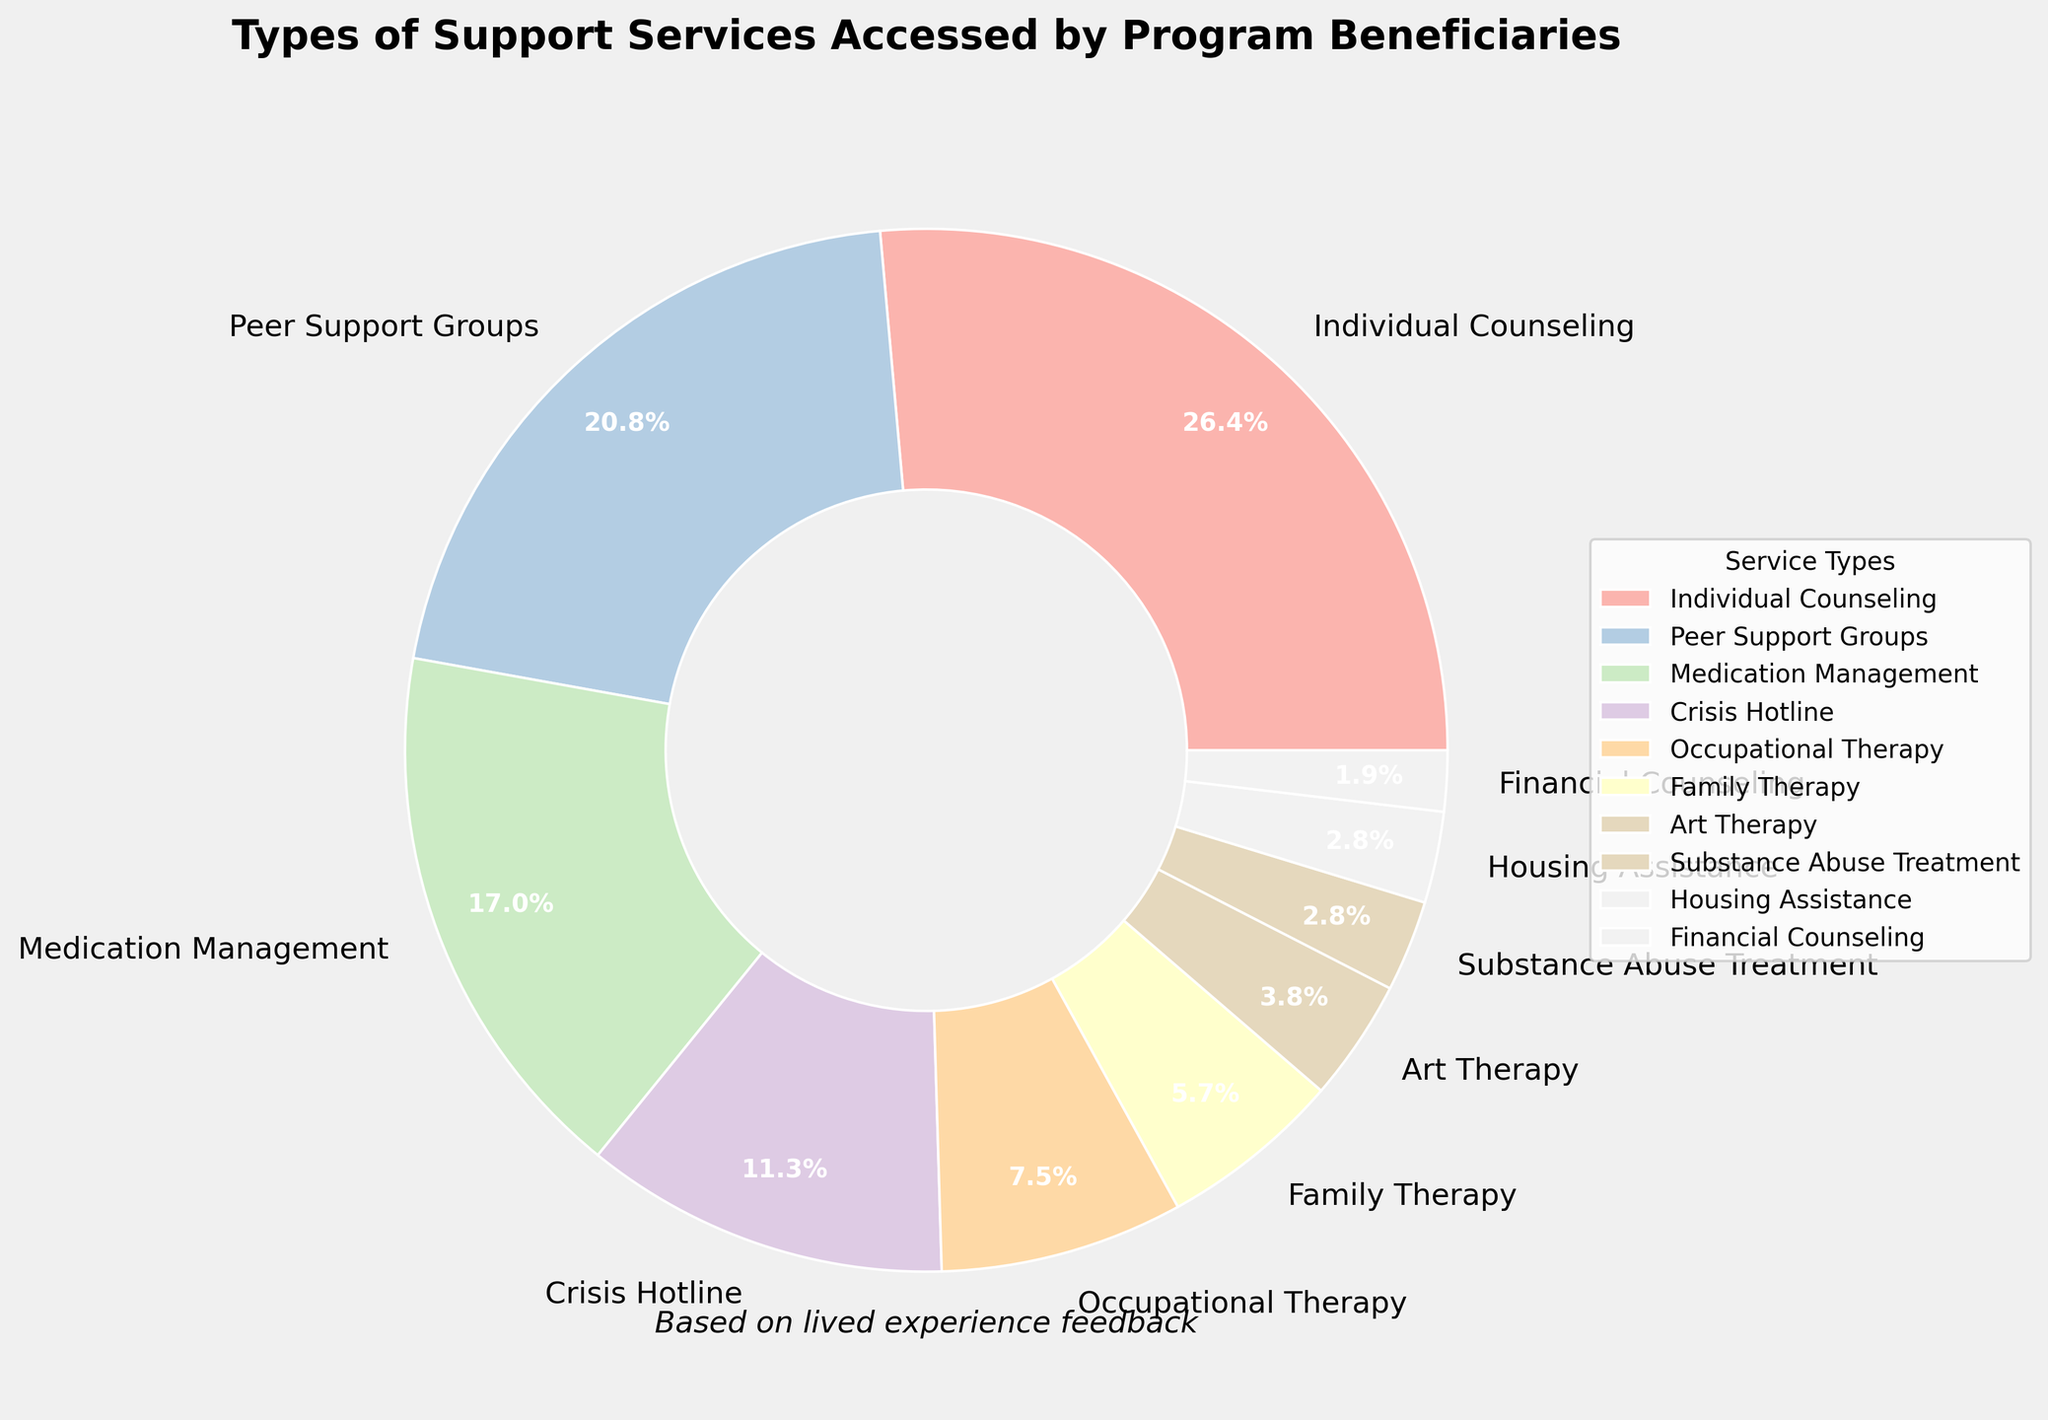Which type of support service is accessed most frequently by program beneficiaries? The pie chart shows that "Individual Counseling" has the largest segment, which means it's accessed the most frequently.
Answer: Individual Counseling What is the difference in percentage between Individual Counseling and Peer Support Groups? Individual Counseling is 28%, and Peer Support Groups are 22%. The difference is 28% - 22% = 6%.
Answer: 6% How do the percentages of Art Therapy and Family Therapy compare? Art Therapy is 4%, and Family Therapy is 6%. To compare, 4% < 6%.
Answer: Family Therapy is higher Which support services collectively make up more than half of the total percentage? Individual Counseling (28%), Peer Support Groups (22%), and Medication Management (18%) collectively are 28% + 22% + 18% = 68%, which is more than half.
Answer: Individual Counseling, Peer Support Groups, Medication Management How much smaller is the percentage for Crisis Hotline compared to Occupational Therapy? Crisis Hotline is 12%, and Occupational Therapy is 8%. The difference is 12% - 8% = 4%.
Answer: 4% Which types of support services have less than 5% usage? The pie chart shows that Art Therapy (4%), Substance Abuse Treatment (3%), Housing Assistance (3%), and Financial Counseling (2%) each have less than 5%.
Answer: Art Therapy, Substance Abuse Treatment, Housing Assistance, Financial Counseling How do the combined percentages of Housing Assistance and Financial Counseling compare to the percentage of Medication Management? Housing Assistance (3%) and Financial Counseling (2%) combined are 3% + 2% = 5%. Medication Management is 18%. Hence, combined percentage 5% < 18%.
Answer: Combined is smaller What percentage of support services is accessed more frequently than Crisis Hotline? Crisis Hotline is at 12%. Services accessed more frequently include Individual Counseling (28%), Peer Support Groups (22%), and Medication Management (18%).
Answer: 68% If you combine the percentages of Family Therapy and Crisis Hotline, what fraction of the chart do they represent? Family Therapy is 6% and Crisis Hotline is 12%. Combined, they are 6% + 12% = 18%. As the total percentage is 100%, the fraction is 18/100 = 0.18.
Answer: 0.18 What is the percentage difference between the most frequently accessed and the least frequently accessed support service? The most frequently accessed is Individual Counseling at 28%. The least frequently accessed is Financial Counseling at 2%. The difference is 28% - 2% = 26%.
Answer: 26% 